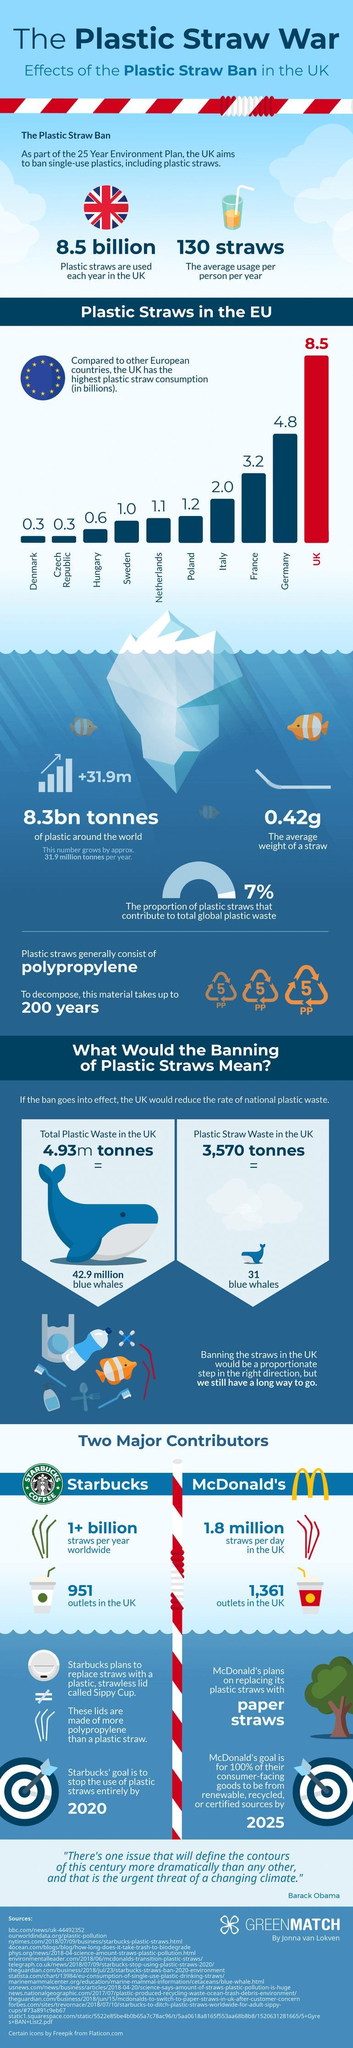How many plastic straws are being used by each Briton annually?
Answer the question with a short phrase. 130 straws What is equivalent to 3,570 tonnes of plastic straw waste? 31 blue whales Which is the major product of Starbucks company? Coffee Which is the materiel used for making plastic straw? polypropylene How much is the plastic straw waste in United Kingdom? 3,570 tonnes What percentage of overall plastic waste is not plastic straw? 93% How many European countries have plastic straw consumption rate less than 1.0 billion? 3 How many outlets of Starbucks is there in UK? 951 Which is the European Country which ranks fourth in consumption of plastic straws? Italy Which is the European Country which ranks second in consumption of plastic straws? Germany 